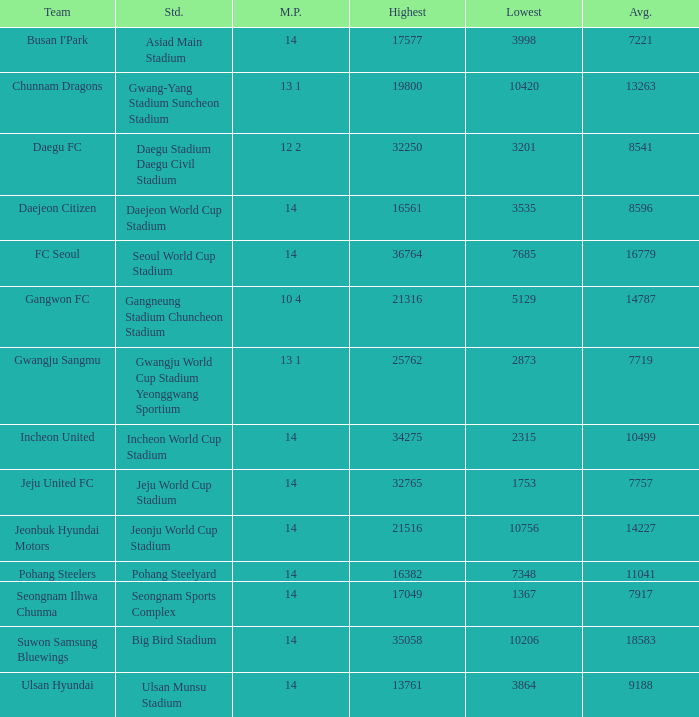How many match played have the highest as 32250? 12 2. 